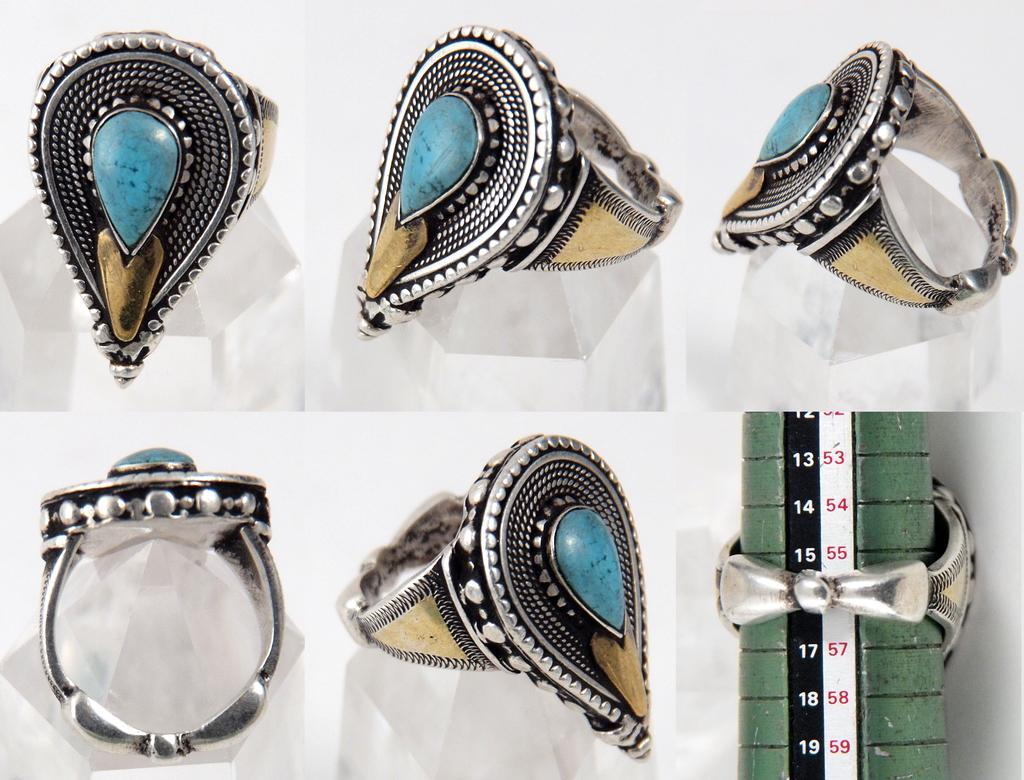What type of objects are present in the image? There are rings and a stick in the image. What colors are the rings? The rings are in blue and white color. What colors are present on the stick? The stick is in blue, white, and black color. What type of straw is being used by the carpenter in the image? There is no carpenter or straw present in the image. What type of work is being done by the person in the image? There is no person or work being done visible in the image. 